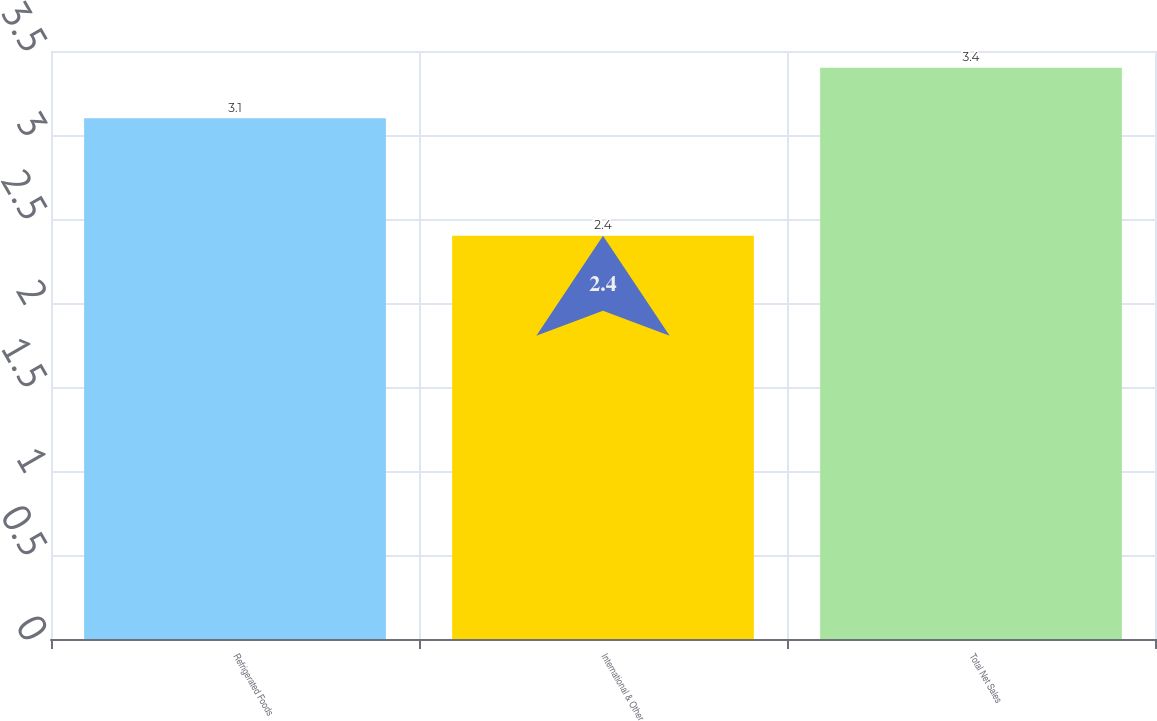<chart> <loc_0><loc_0><loc_500><loc_500><bar_chart><fcel>Refrigerated Foods<fcel>International & Other<fcel>Total Net Sales<nl><fcel>3.1<fcel>2.4<fcel>3.4<nl></chart> 